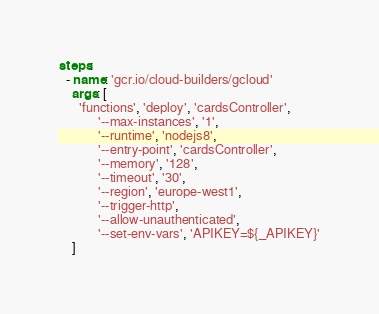Convert code to text. <code><loc_0><loc_0><loc_500><loc_500><_YAML_>steps:
  - name: 'gcr.io/cloud-builders/gcloud'
    args: [
      'functions', 'deploy', 'cardsController',
            '--max-instances', '1',
            '--runtime', 'nodejs8',
            '--entry-point', 'cardsController',
            '--memory', '128',
            '--timeout', '30',
            '--region', 'europe-west1',
            '--trigger-http',
            '--allow-unauthenticated',
            '--set-env-vars', 'APIKEY=${_APIKEY}'
    ]</code> 